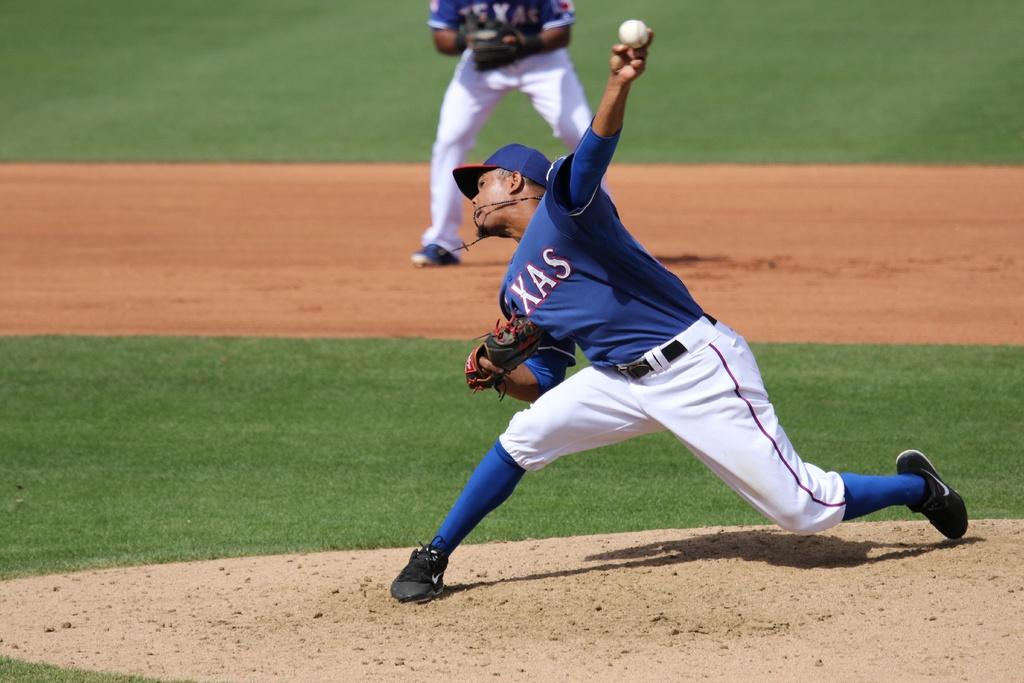<image>
Relay a brief, clear account of the picture shown. A baseball pitcher pitching a ball that has XAS on his shirt with a player ready to catch in the background. 